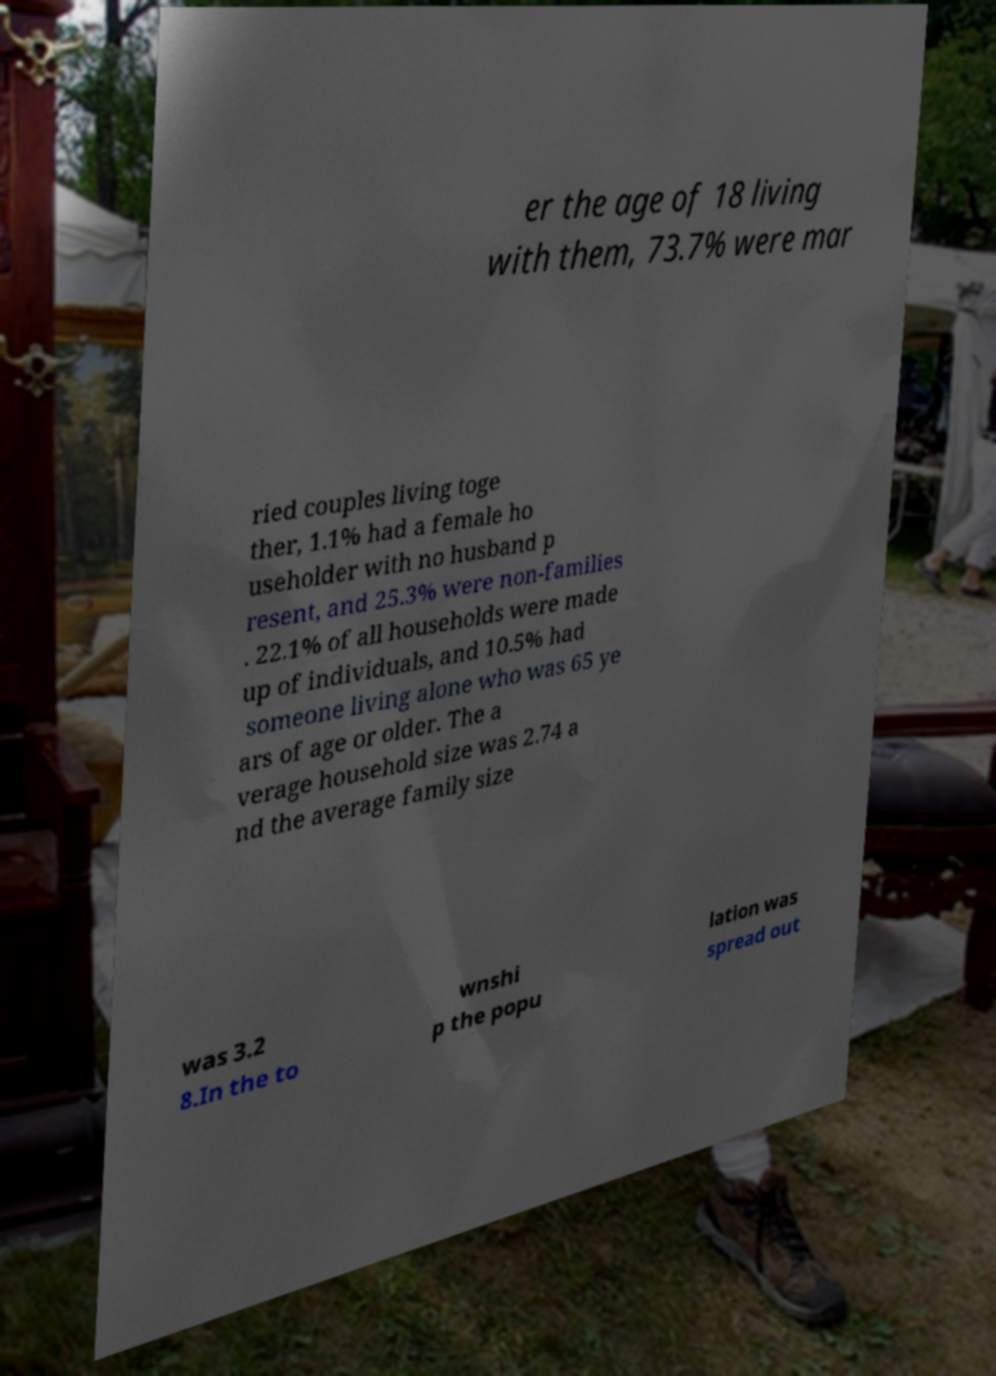Could you assist in decoding the text presented in this image and type it out clearly? er the age of 18 living with them, 73.7% were mar ried couples living toge ther, 1.1% had a female ho useholder with no husband p resent, and 25.3% were non-families . 22.1% of all households were made up of individuals, and 10.5% had someone living alone who was 65 ye ars of age or older. The a verage household size was 2.74 a nd the average family size was 3.2 8.In the to wnshi p the popu lation was spread out 